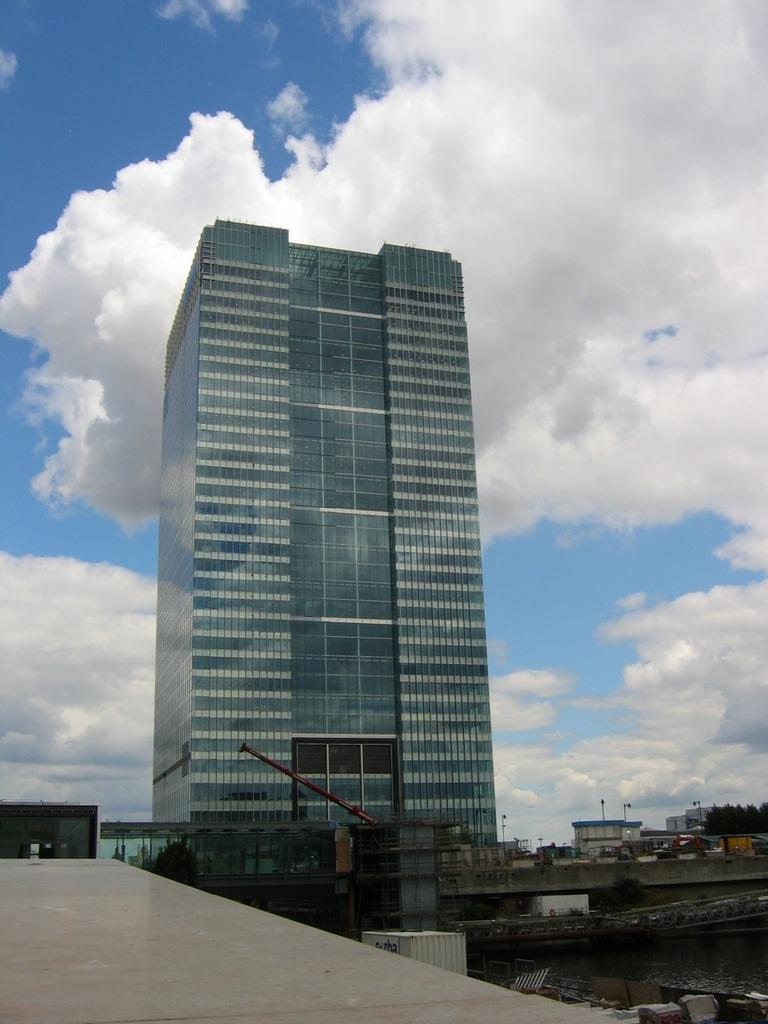What is the main subject of the image? There is a building in the image. Can you describe any other structures in the image? Yes, there are small buildings visible in the background of the image. What can be seen in the sky at the top of the image? There are clouds visible in the sky at the top of the image. Is there an earthquake happening in the image? There is no indication of an earthquake in the image. Can you see a volleyball being played in the image? There is no volleyball or any indication of a game being played in the image. 